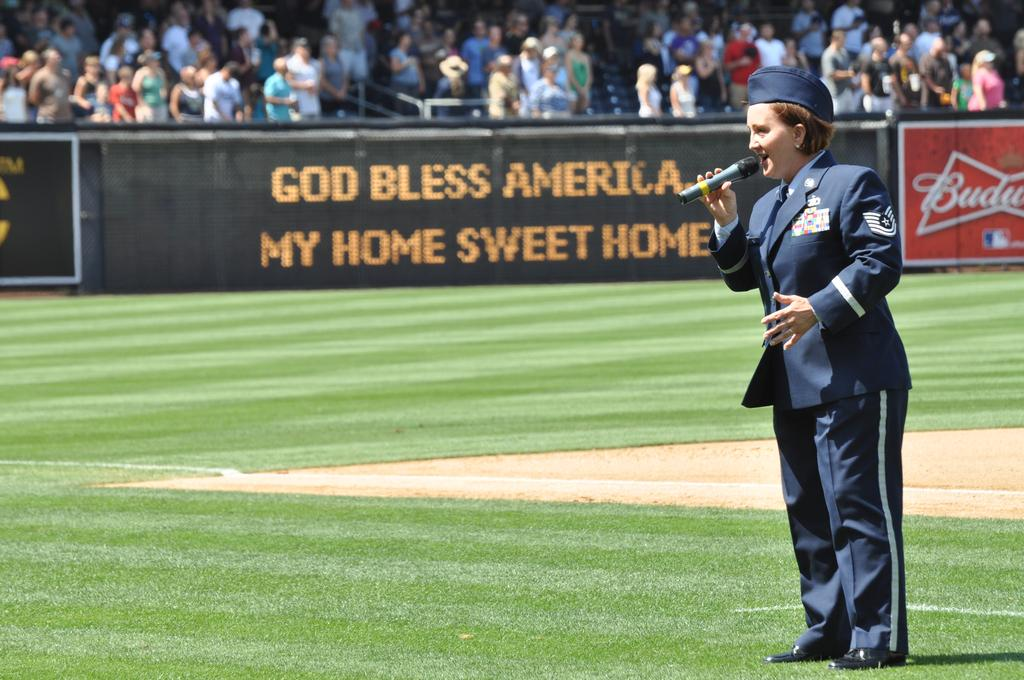Provide a one-sentence caption for the provided image. In the center of the baseball field, a female soldier is singing with a sign in front of the stands that says God Bless America, My Home Sweet Home. 